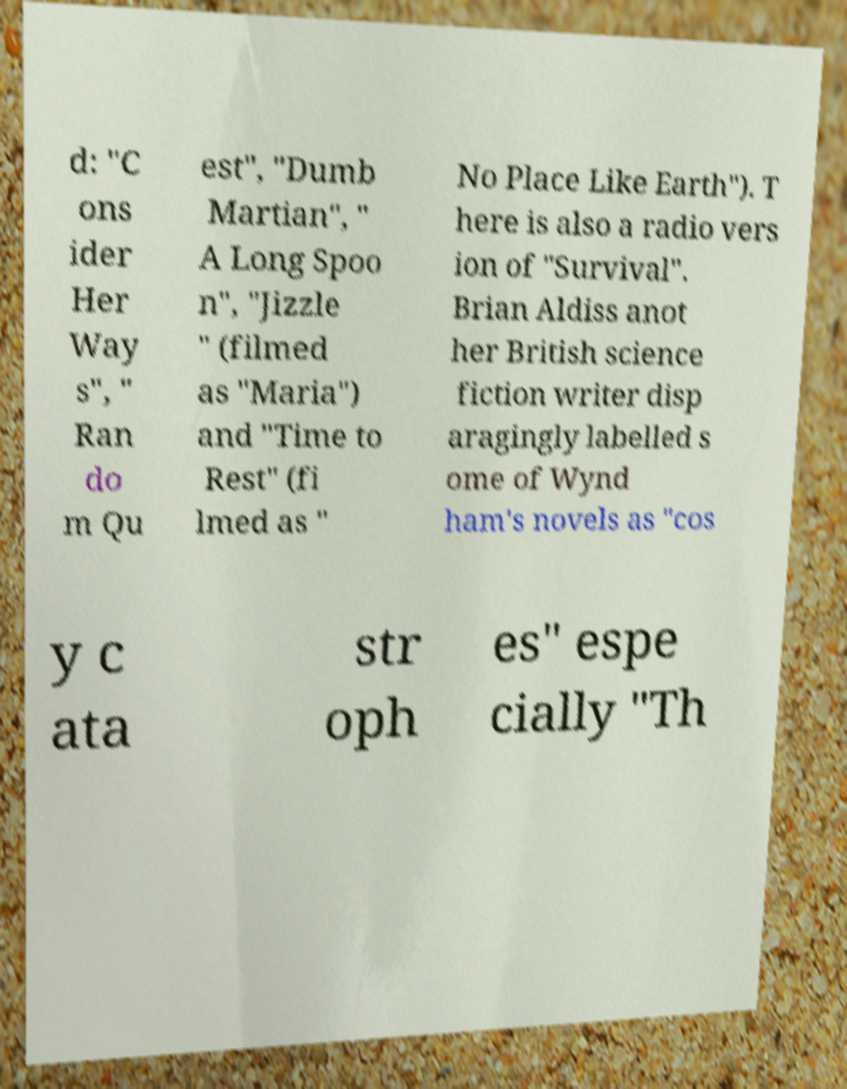Could you assist in decoding the text presented in this image and type it out clearly? d: "C ons ider Her Way s", " Ran do m Qu est", "Dumb Martian", " A Long Spoo n", "Jizzle " (filmed as "Maria") and "Time to Rest" (fi lmed as " No Place Like Earth"). T here is also a radio vers ion of "Survival". Brian Aldiss anot her British science fiction writer disp aragingly labelled s ome of Wynd ham's novels as "cos y c ata str oph es" espe cially "Th 